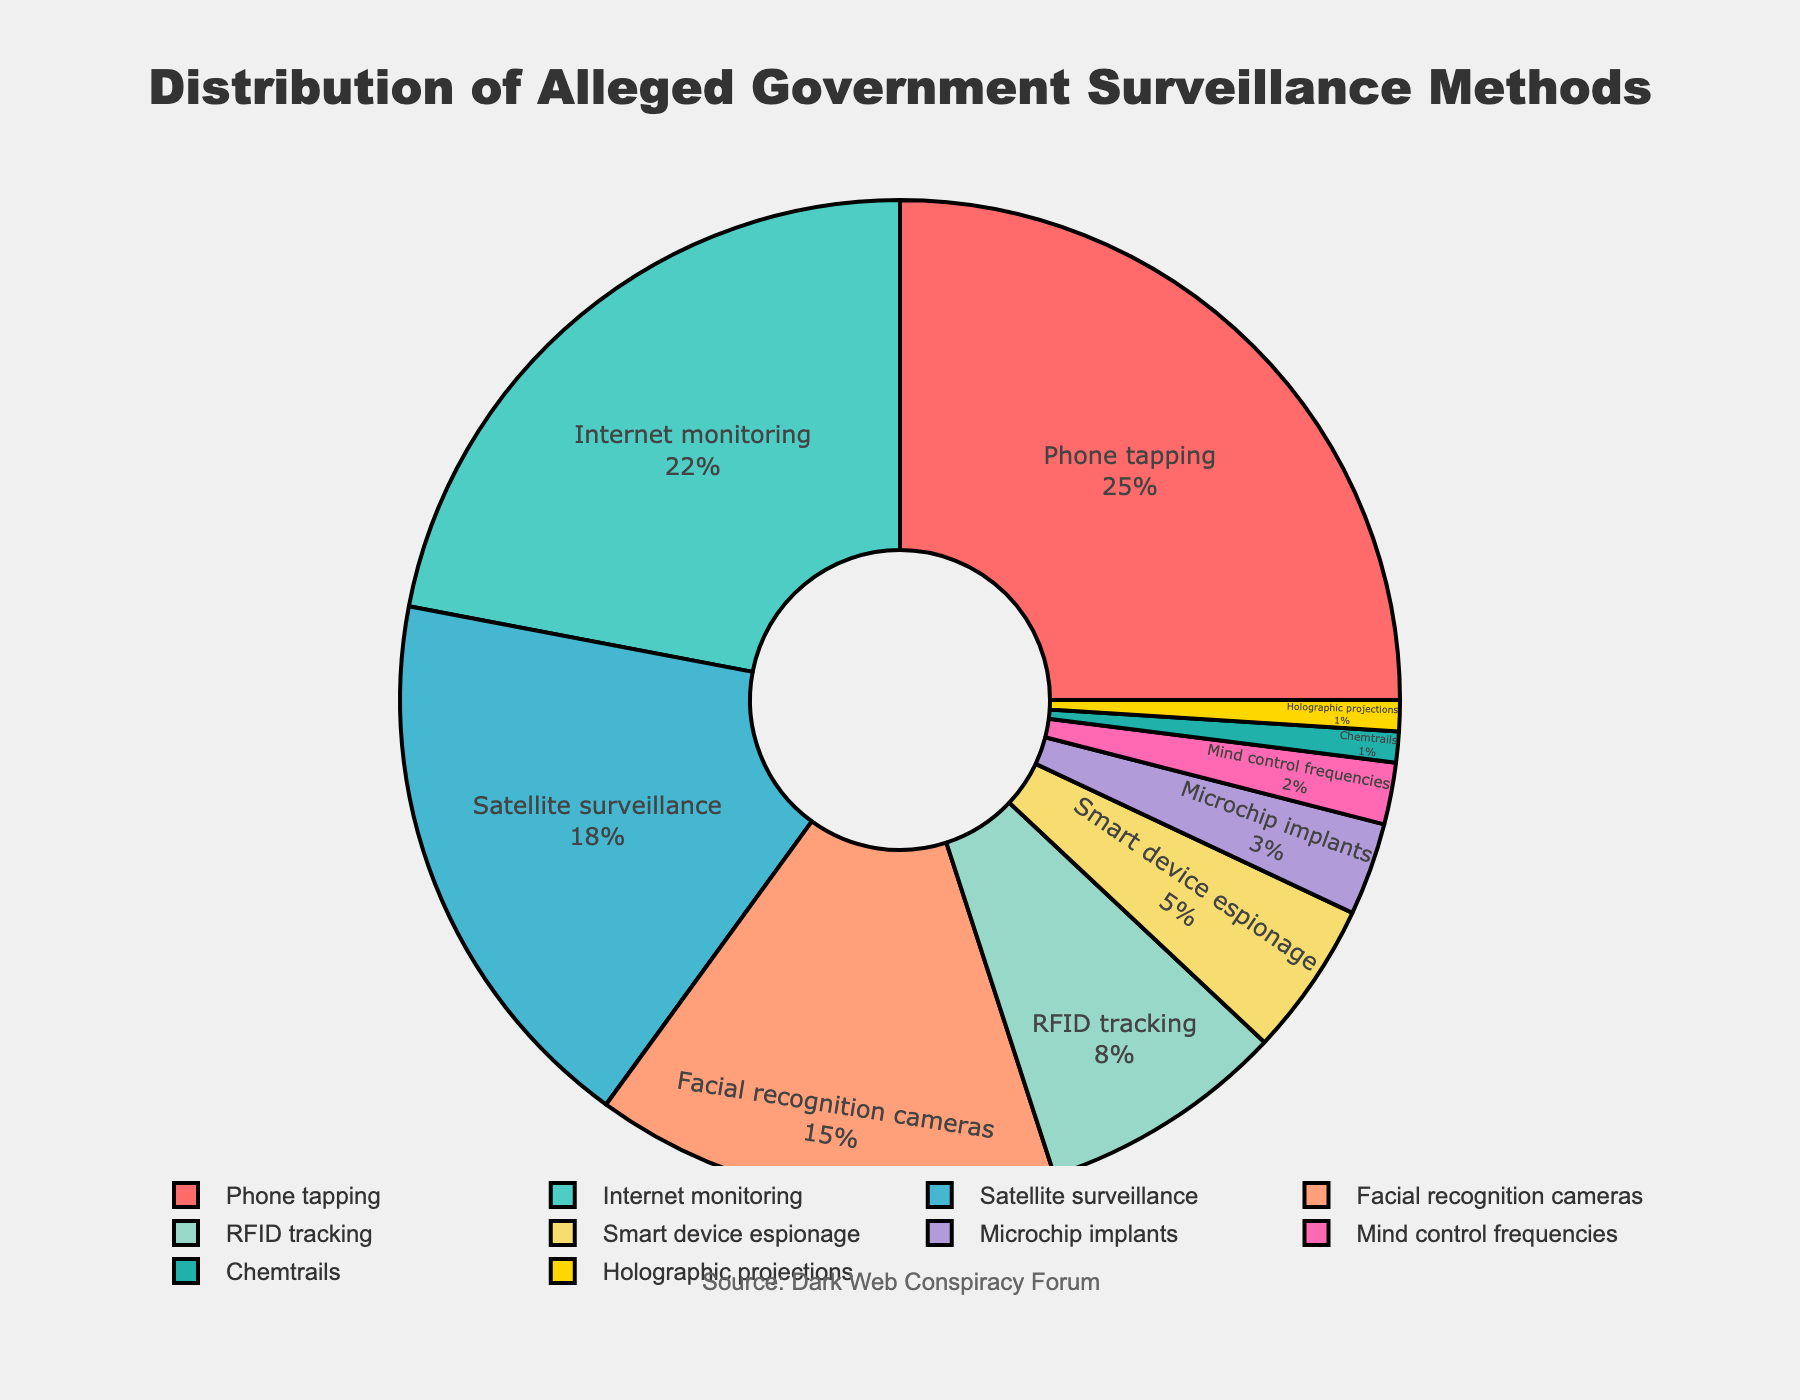Which surveillance method has the highest percentage? By looking at the pie chart, the segment with the largest area represents the surveillance method with the highest percentage. Phone tapping has the largest segment.
Answer: Phone tapping Which methods collectively constitute over 50% of the surveillance? Phone tapping (25%), Internet monitoring (22%), and Satellite surveillance (18%) can be summed up to see if they exceed 50%. 25% + 22% +18% = 65%, which is greater than 50%.
Answer: Phone tapping, Internet monitoring, Satellite surveillance What is the difference in percentage between RFID tracking and Smart device espionage? Look at the pie chart and find the percentages of RFID tracking and Smart device espionage. Subtract the smaller percentage from the larger one. RFID tracking is 8%, while Smart device espionage is 5%. 8% - 5% = 3%.
Answer: 3% Which method has exactly half the percentage of Internet monitoring? First, find the percentage of Internet monitoring (22%). Half of 22% is 11%. Look for the segment corresponding to 11%. No such value exists, thus no method corresponds to that criteria.
Answer: None Which pie segments are colored in shades of green? Identify segments with green shades. The segment for Internet monitoring is shaded teal (a shade of green), and Satellite surveillance is another greenish shade.
Answer: Internet monitoring, Satellite surveillance What is the combined percentage of the four least represented methods? Identify and sum the percentages of the least represented methods (Mind control frequencies, Chemtrails, Holographic projections, Microchip implants). 2% + 1% + 1% + 3% = 7%.
Answer: 7% Is the percentage of Facial recognition cameras greater than the combined percentage of Microchip implants and Mind control frequencies? Find the percentage for Facial recognition cameras (15%) and the combined percentage for Microchip implants (3%) and Mind control frequencies (2%). Compare 15% with 3% + 2% = 5%. 15% is greater than 5%.
Answer: Yes 